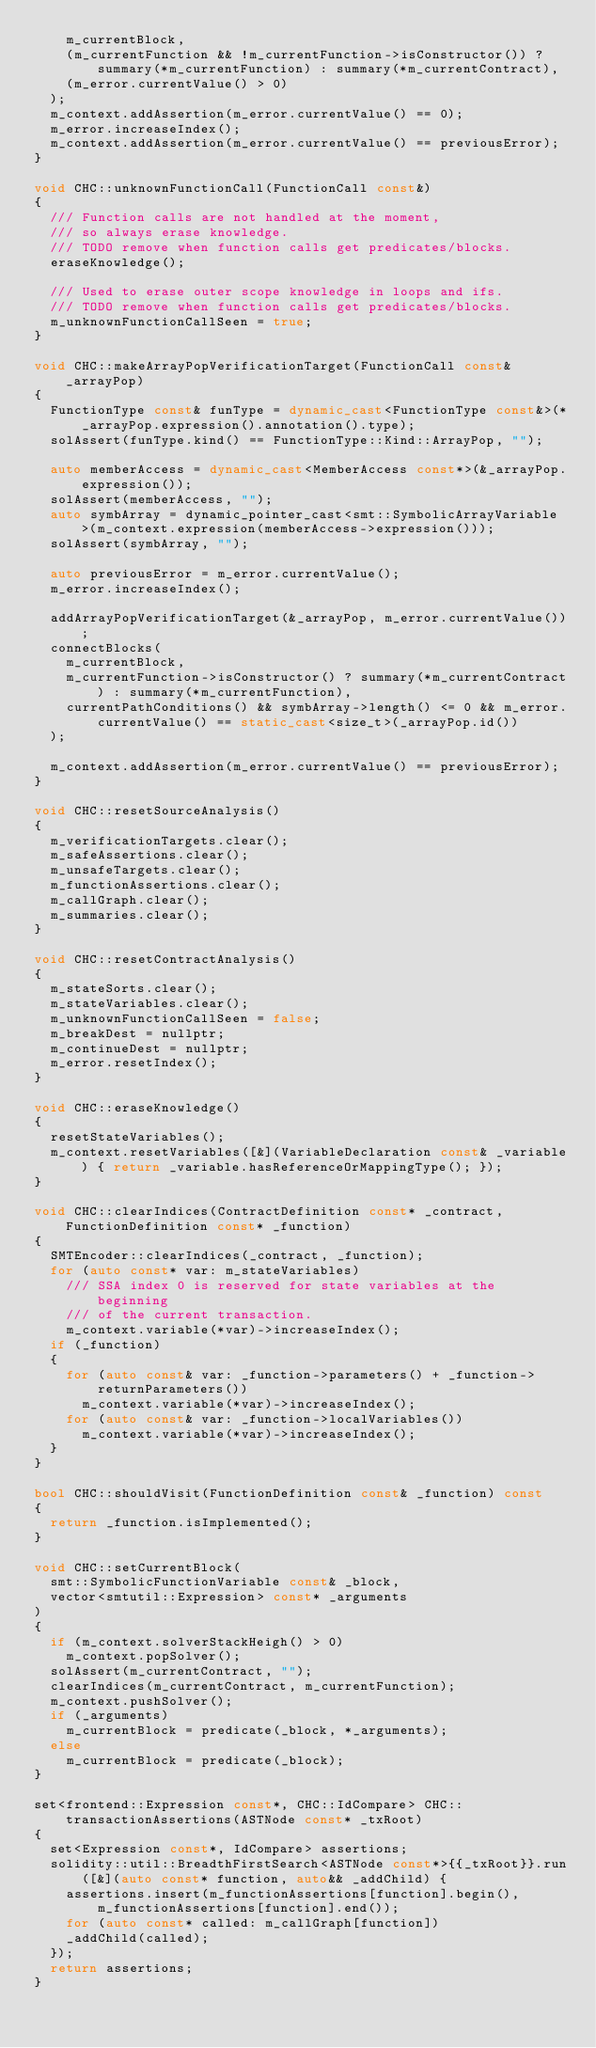Convert code to text. <code><loc_0><loc_0><loc_500><loc_500><_C++_>		m_currentBlock,
		(m_currentFunction && !m_currentFunction->isConstructor()) ? summary(*m_currentFunction) : summary(*m_currentContract),
		(m_error.currentValue() > 0)
	);
	m_context.addAssertion(m_error.currentValue() == 0);
	m_error.increaseIndex();
	m_context.addAssertion(m_error.currentValue() == previousError);
}

void CHC::unknownFunctionCall(FunctionCall const&)
{
	/// Function calls are not handled at the moment,
	/// so always erase knowledge.
	/// TODO remove when function calls get predicates/blocks.
	eraseKnowledge();

	/// Used to erase outer scope knowledge in loops and ifs.
	/// TODO remove when function calls get predicates/blocks.
	m_unknownFunctionCallSeen = true;
}

void CHC::makeArrayPopVerificationTarget(FunctionCall const& _arrayPop)
{
	FunctionType const& funType = dynamic_cast<FunctionType const&>(*_arrayPop.expression().annotation().type);
	solAssert(funType.kind() == FunctionType::Kind::ArrayPop, "");

	auto memberAccess = dynamic_cast<MemberAccess const*>(&_arrayPop.expression());
	solAssert(memberAccess, "");
	auto symbArray = dynamic_pointer_cast<smt::SymbolicArrayVariable>(m_context.expression(memberAccess->expression()));
	solAssert(symbArray, "");

	auto previousError = m_error.currentValue();
	m_error.increaseIndex();

	addArrayPopVerificationTarget(&_arrayPop, m_error.currentValue());
	connectBlocks(
		m_currentBlock,
		m_currentFunction->isConstructor() ? summary(*m_currentContract) : summary(*m_currentFunction),
		currentPathConditions() && symbArray->length() <= 0 && m_error.currentValue() == static_cast<size_t>(_arrayPop.id())
	);

	m_context.addAssertion(m_error.currentValue() == previousError);
}

void CHC::resetSourceAnalysis()
{
	m_verificationTargets.clear();
	m_safeAssertions.clear();
	m_unsafeTargets.clear();
	m_functionAssertions.clear();
	m_callGraph.clear();
	m_summaries.clear();
}

void CHC::resetContractAnalysis()
{
	m_stateSorts.clear();
	m_stateVariables.clear();
	m_unknownFunctionCallSeen = false;
	m_breakDest = nullptr;
	m_continueDest = nullptr;
	m_error.resetIndex();
}

void CHC::eraseKnowledge()
{
	resetStateVariables();
	m_context.resetVariables([&](VariableDeclaration const& _variable) { return _variable.hasReferenceOrMappingType(); });
}

void CHC::clearIndices(ContractDefinition const* _contract, FunctionDefinition const* _function)
{
	SMTEncoder::clearIndices(_contract, _function);
	for (auto const* var: m_stateVariables)
		/// SSA index 0 is reserved for state variables at the beginning
		/// of the current transaction.
		m_context.variable(*var)->increaseIndex();
	if (_function)
	{
		for (auto const& var: _function->parameters() + _function->returnParameters())
			m_context.variable(*var)->increaseIndex();
		for (auto const& var: _function->localVariables())
			m_context.variable(*var)->increaseIndex();
	}
}

bool CHC::shouldVisit(FunctionDefinition const& _function) const
{
	return _function.isImplemented();
}

void CHC::setCurrentBlock(
	smt::SymbolicFunctionVariable const& _block,
	vector<smtutil::Expression> const* _arguments
)
{
	if (m_context.solverStackHeigh() > 0)
		m_context.popSolver();
	solAssert(m_currentContract, "");
	clearIndices(m_currentContract, m_currentFunction);
	m_context.pushSolver();
	if (_arguments)
		m_currentBlock = predicate(_block, *_arguments);
	else
		m_currentBlock = predicate(_block);
}

set<frontend::Expression const*, CHC::IdCompare> CHC::transactionAssertions(ASTNode const* _txRoot)
{
	set<Expression const*, IdCompare> assertions;
	solidity::util::BreadthFirstSearch<ASTNode const*>{{_txRoot}}.run([&](auto const* function, auto&& _addChild) {
		assertions.insert(m_functionAssertions[function].begin(), m_functionAssertions[function].end());
		for (auto const* called: m_callGraph[function])
		_addChild(called);
	});
	return assertions;
}
</code> 